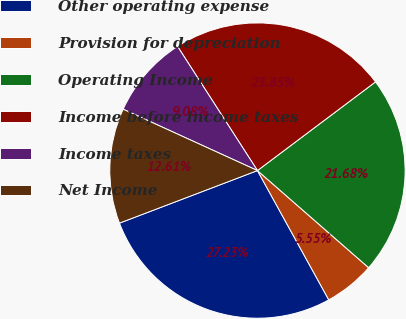<chart> <loc_0><loc_0><loc_500><loc_500><pie_chart><fcel>Other operating expense<fcel>Provision for depreciation<fcel>Operating Income<fcel>Income before income taxes<fcel>Income taxes<fcel>Net Income<nl><fcel>27.23%<fcel>5.55%<fcel>21.68%<fcel>23.85%<fcel>9.08%<fcel>12.61%<nl></chart> 